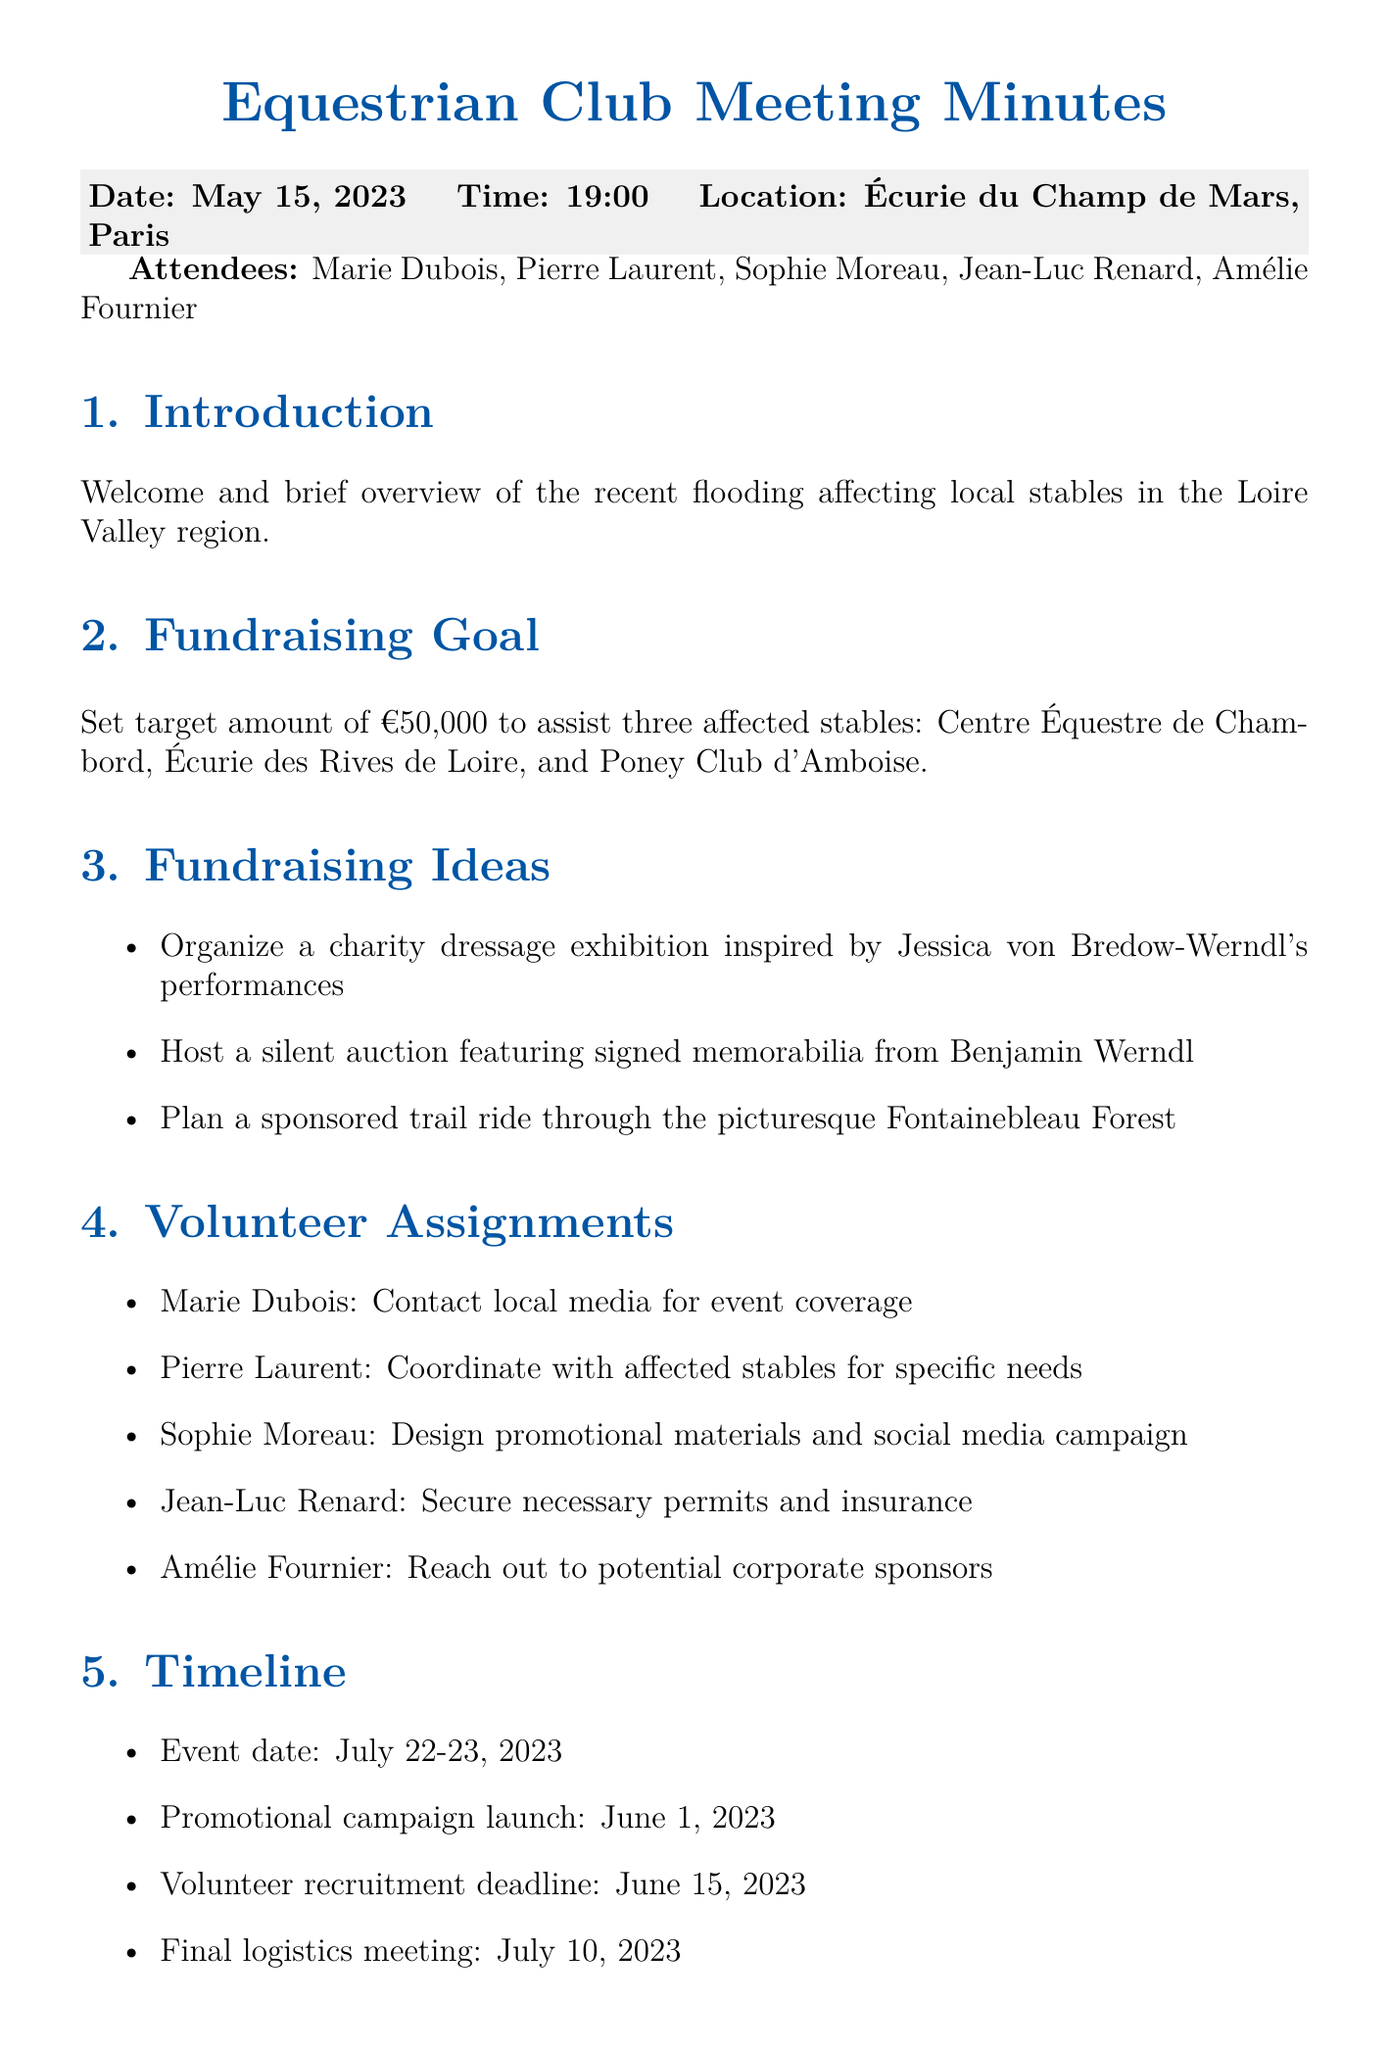What is the meeting date? The meeting date is explicitly mentioned in the document as "May 15, 2023."
Answer: May 15, 2023 What is the location of the meeting? The location of the meeting is stated as "Écurie du Champ de Mars, Paris."
Answer: Écurie du Champ de Mars, Paris What is the fundraising goal amount? The target fundraising goal is set to assist the affected stables, specifically listed as "€50,000."
Answer: €50,000 How many affected stables are mentioned? The document lists three specific stables affected by the flooding.
Answer: Three Who is responsible for designing promotional materials? The assignment for designing promotional materials is given to "Sophie Moreau."
Answer: Sophie Moreau When is the follow-up meeting scheduled? The document specifies the date for the follow-up meeting as "June 1."
Answer: June 1 What type of event is planned to raise funds? The document mentions organizing a "charity dressage exhibition."
Answer: charity dressage exhibition Which forest is mentioned for the sponsored trail ride? The specific forest mentioned for the trail ride is the "Fontainebleau Forest."
Answer: Fontainebleau Forest What is the promotional campaign launch date? The document states that the promotional campaign is set to launch on "June 1, 2023."
Answer: June 1, 2023 